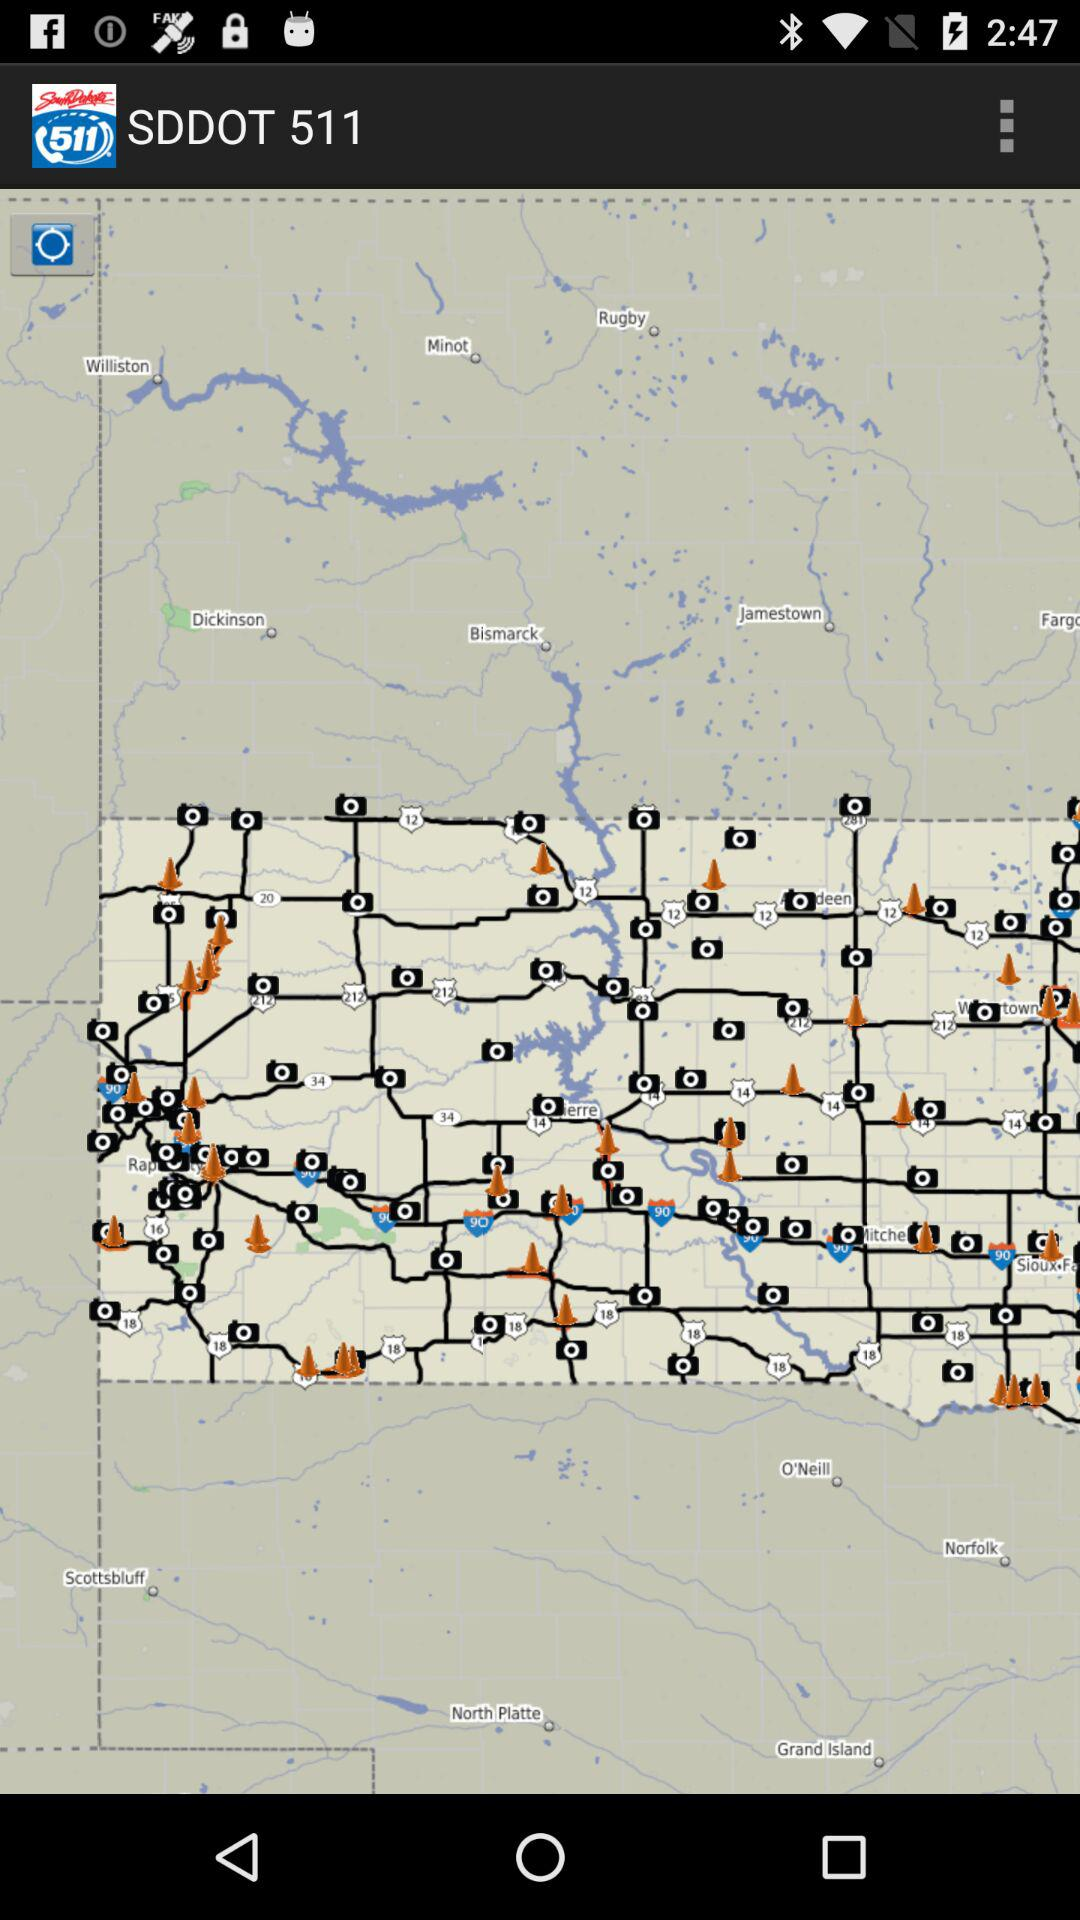What is the application name? The application name is "SDDOT 511". 